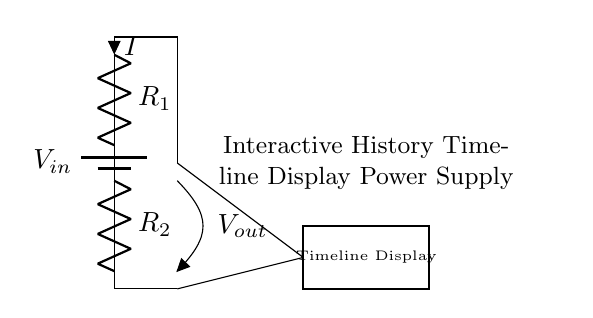What is the input voltage of the circuit? The input voltage is indicated by the label $V_{in}$ connected to the battery. This represents the voltage supplied to the voltage divider circuit.
Answer: $V_{in}$ What are the two resistors labeled in the circuit? The circuit shows two resistors: $R_1$ and $R_2$. They are essential components of the voltage divider used for dropping the voltage.
Answer: $R_1$, $R_2$ What is the current direction in the circuit? The current, labeled as $I$, flows through resistor $R_1$ and subsequently through resistor $R_2$, as indicated by the arrow showing the current direction.
Answer: Downward What is the output voltage in the circuit? The output voltage is labeled as $V_{out}$ at the junction between the two resistors. It represents the potential difference after $R_1$ and $R_2$.
Answer: $V_{out}$ What does the rectangle at the bottom symbolize? The rectangle represents the interactive history timeline display which is powered by the circuit. It visually indicates the component being supplied.
Answer: Timeline Display How does $R_1$ affect $V_{out}$ compared to $R_2$? Resistor $R_1$ influences the voltage drop across it, affecting the output voltage $V_{out}$. A larger $R_1$ would yield a higher $V_{out}$ compared to a smaller $R_1$ when paired with a constant $R_2$.
Answer: Higher $R_1$, higher $V_{out}$ What is the purpose of this voltage divider circuit? The voltage divider circuit is designed to reduce the input voltage to a level suitable for the interactive history timeline display, ensuring proper operation without damaging the display.
Answer: Power supply 